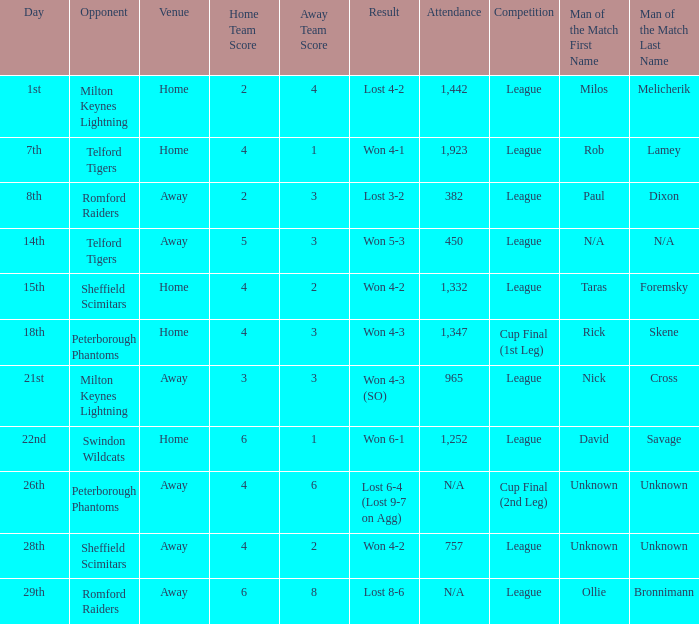What was the date when the opponent was Sheffield Scimitars and the venue was Home? 15th. 